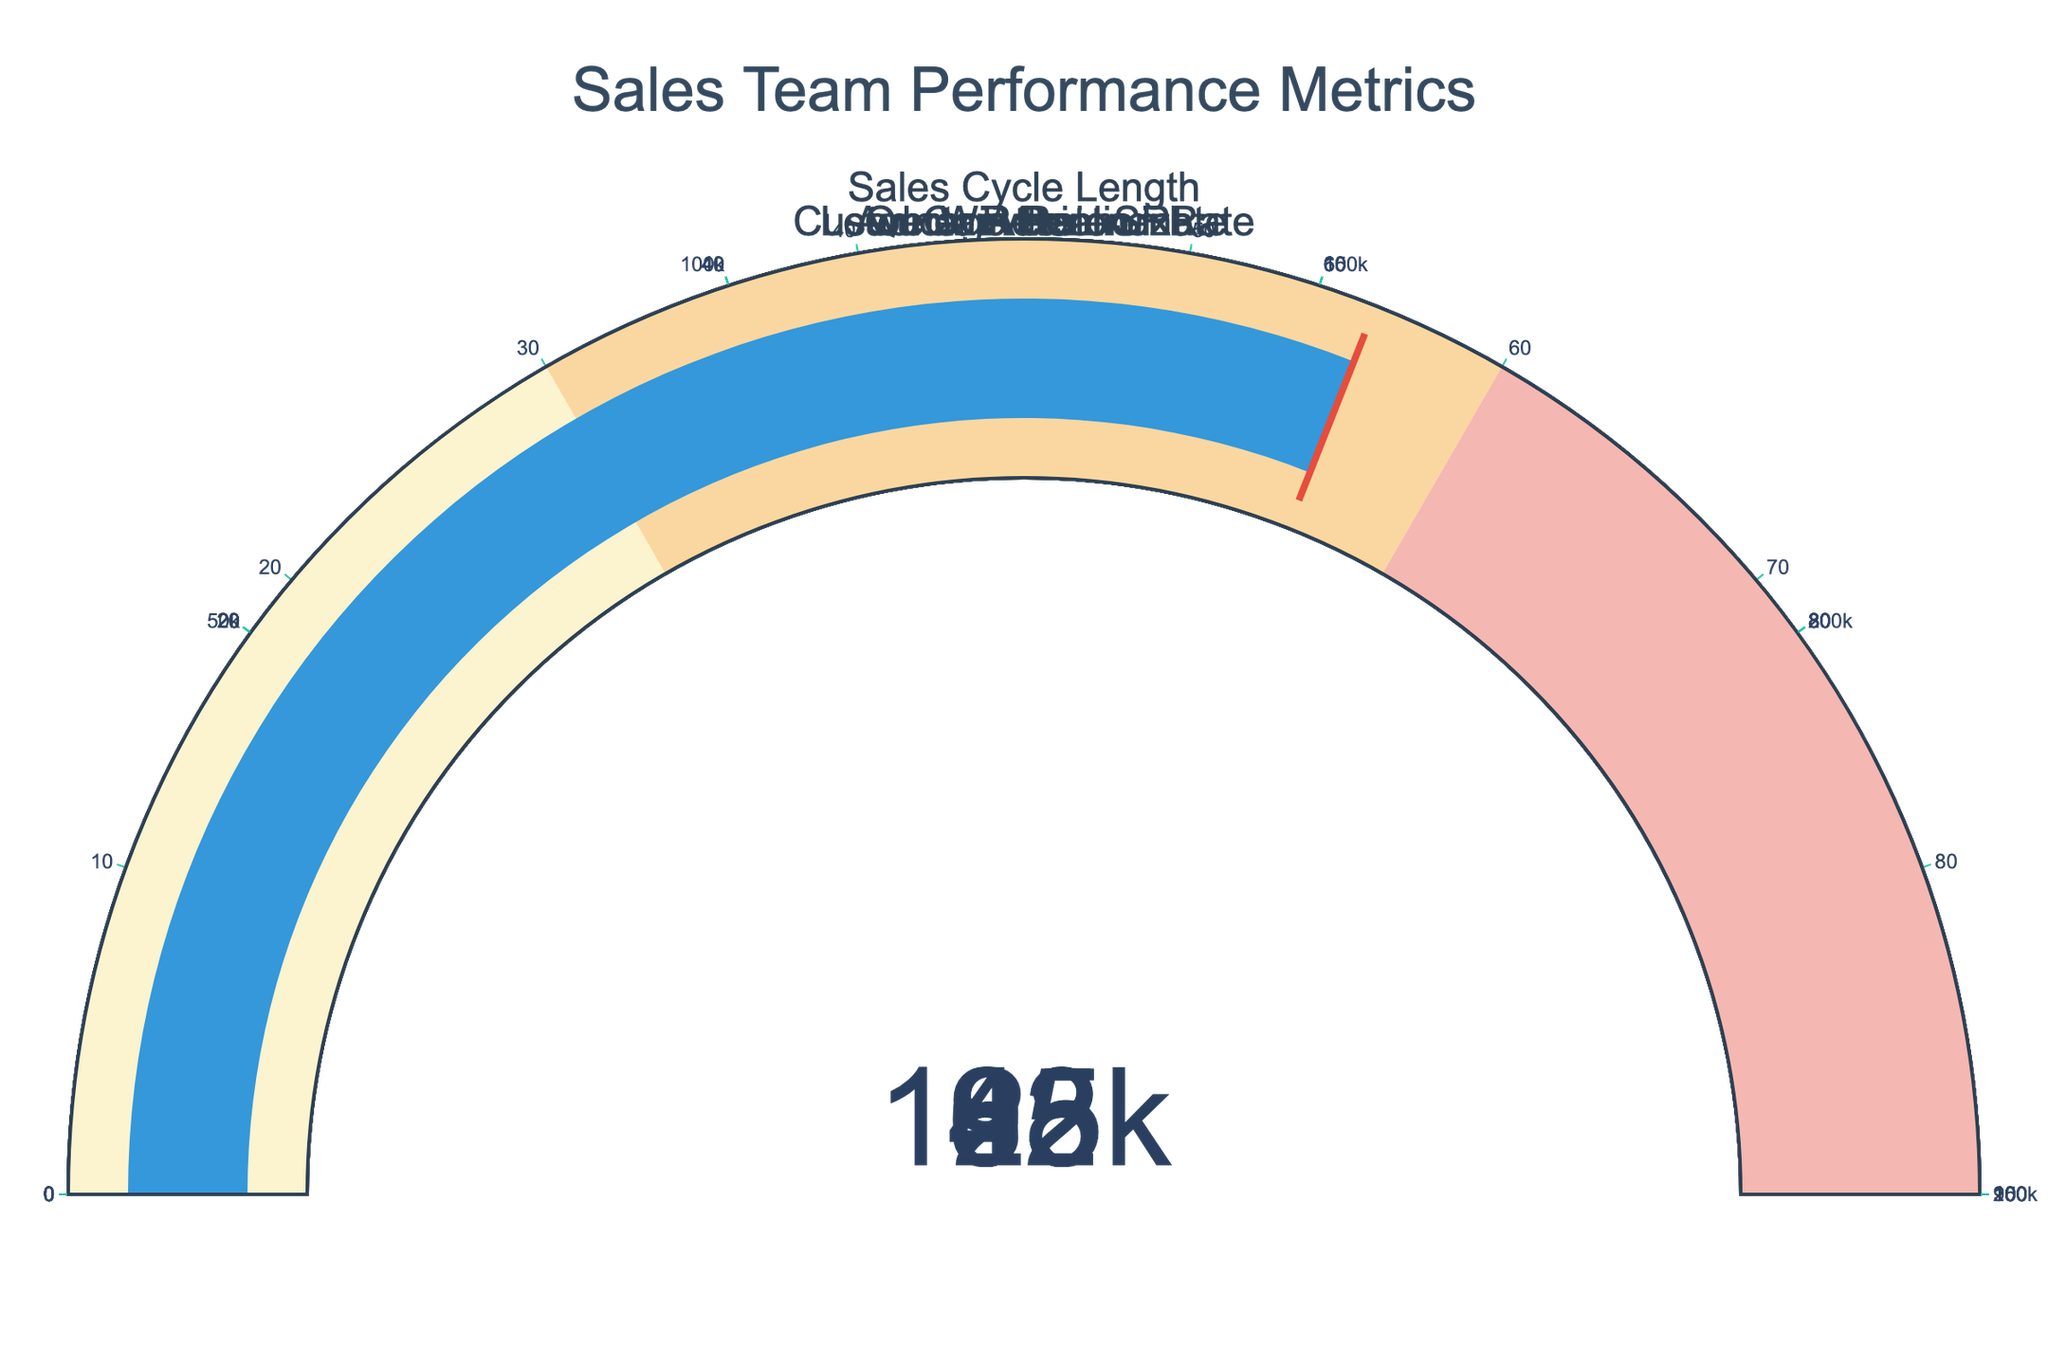How many sales team performance metrics are visualized in the figure? The figure displays gauges for each metric, and counting them reveals a total of six metrics.
Answer: Six What is the highest value displayed on any of the gauges? By looking at all the values on the gauges, we can see that the highest value is for Quota Attainment which is 93.
Answer: 93 Which metric has the lowest value displayed on the gauge? Observing all the values on the gauges, the lowest value is for the Win Rate, which is 62.
Answer: Win Rate What is the combined total value of Lead Conversion Rate and Win Rate? Adding the values of Lead Conversion Rate (68) and Win Rate (62) together, we get 68 + 62 = 130.
Answer: 130 Which metrics have values greater than 80? By checking each gauge, the values greater than 80 are Customer Retention Rate (82) and Quota Attainment (93).
Answer: Customer Retention Rate, Quota Attainment What is the average value of all the displayed metrics? First, sum up all the values: 68 (Lead Conversion Rate) + 125000 (Average Deal Size) + 45 (Sales Cycle Length) + 82 (Customer Retention Rate) + 93 (Quota Attainment) + 62 (Win Rate) = 125350. Then divide by the number of metrics (6), giving us 125350 / 6 = 20891.67.
Answer: 20891.67 What value is shown for the gauge with the highest maximum range? The gauge with the highest maximum range is the Average Deal Size (250000), and its value is 125000.
Answer: 125000 Which metric's value exactly matches its threshold indicator? Examining the threshold lines, the metric values that match their thresholds exactly are all given metrics because they match their threshold values: 68, 125000, 45, 82, 93, and 62 based on the provided code.
Answer: All metrics If the Sales Cycle Length decreased by 10 days, what would its new value be? Subtracting 10 from the current Sales Cycle Length value of 45, we get 45 - 10 = 35.
Answer: 35 